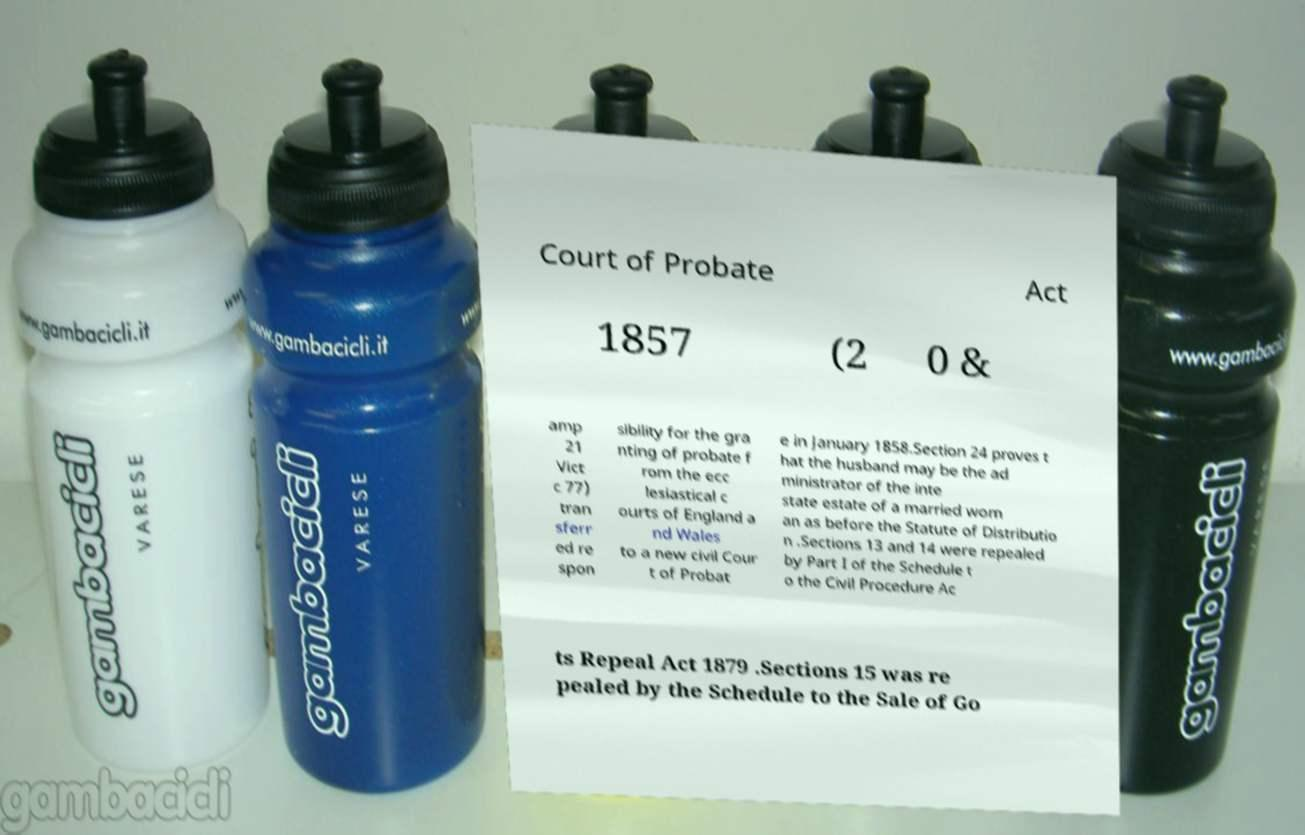Can you read and provide the text displayed in the image?This photo seems to have some interesting text. Can you extract and type it out for me? Court of Probate Act 1857 (2 0 & amp 21 Vict c 77) tran sferr ed re spon sibility for the gra nting of probate f rom the ecc lesiastical c ourts of England a nd Wales to a new civil Cour t of Probat e in January 1858.Section 24 proves t hat the husband may be the ad ministrator of the inte state estate of a married wom an as before the Statute of Distributio n .Sections 13 and 14 were repealed by Part I of the Schedule t o the Civil Procedure Ac ts Repeal Act 1879 .Sections 15 was re pealed by the Schedule to the Sale of Go 